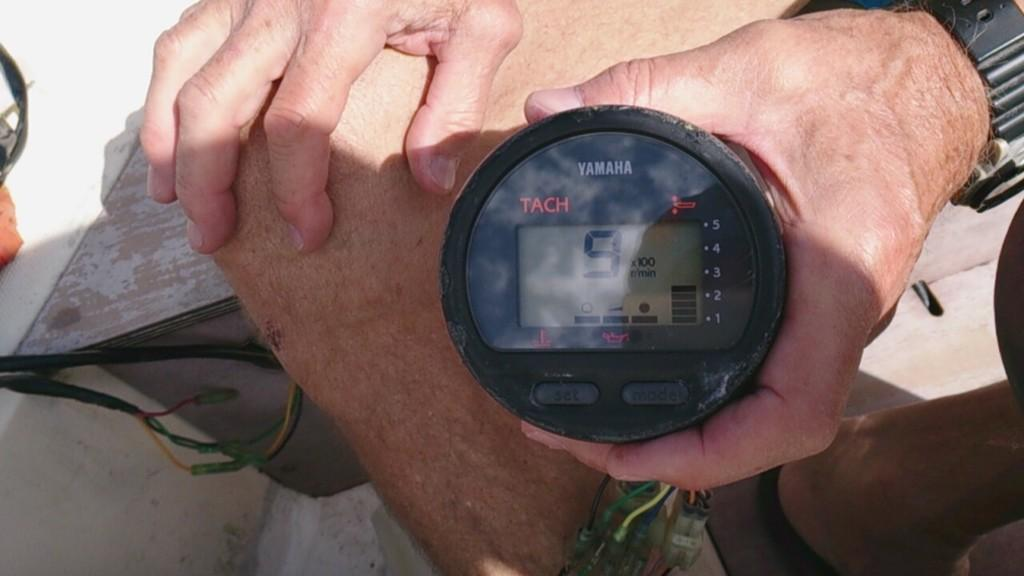<image>
Write a terse but informative summary of the picture. The number 9 on a Yamaha brand device. 